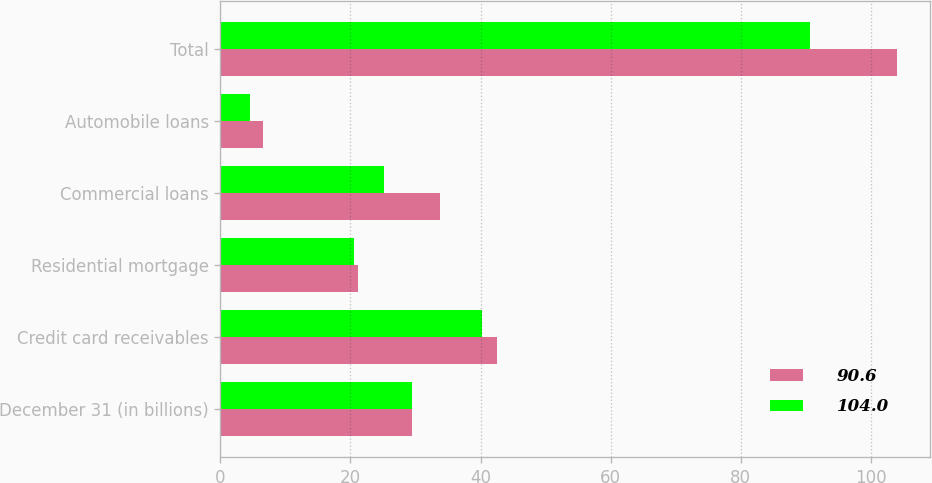Convert chart. <chart><loc_0><loc_0><loc_500><loc_500><stacked_bar_chart><ecel><fcel>December 31 (in billions)<fcel>Credit card receivables<fcel>Residential mortgage<fcel>Commercial loans<fcel>Automobile loans<fcel>Total<nl><fcel>90.6<fcel>29.5<fcel>42.6<fcel>21.1<fcel>33.8<fcel>6.5<fcel>104<nl><fcel>104<fcel>29.5<fcel>40.2<fcel>20.6<fcel>25.2<fcel>4.5<fcel>90.6<nl></chart> 